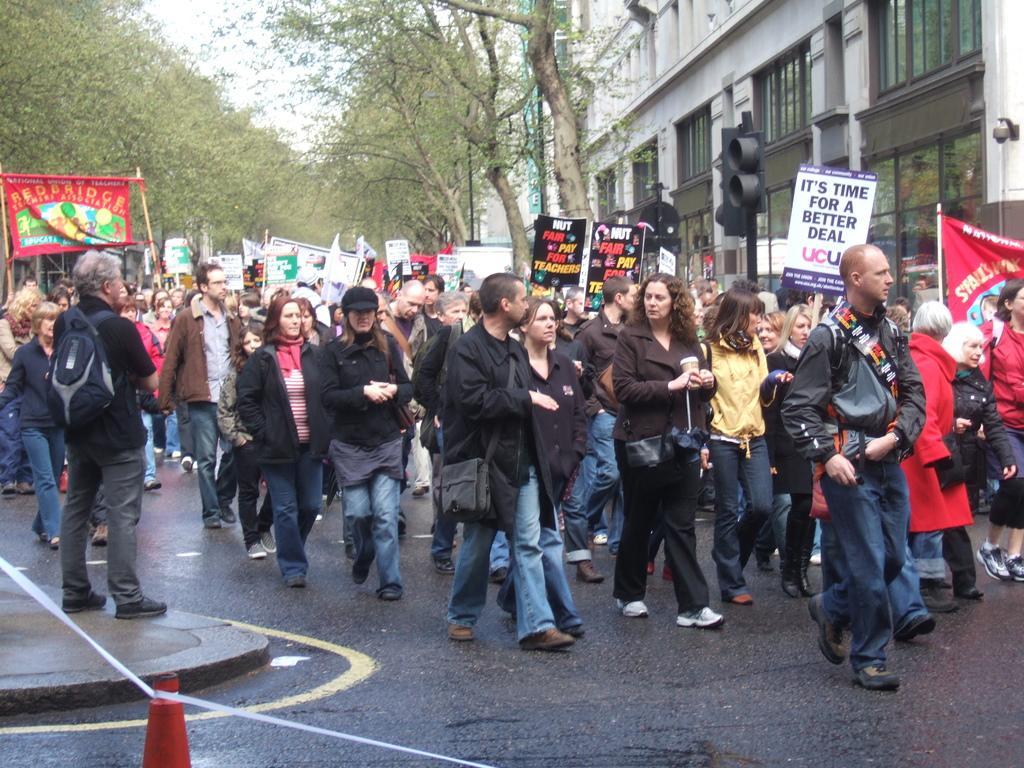Describe this image in one or two sentences. In this image I see number of people who are on the path and I see that most of them are holding banners and boards in their hands and I see something is written on the boards and banners. In the background I see the trees and the buildings and I see the traffic signal over here. 